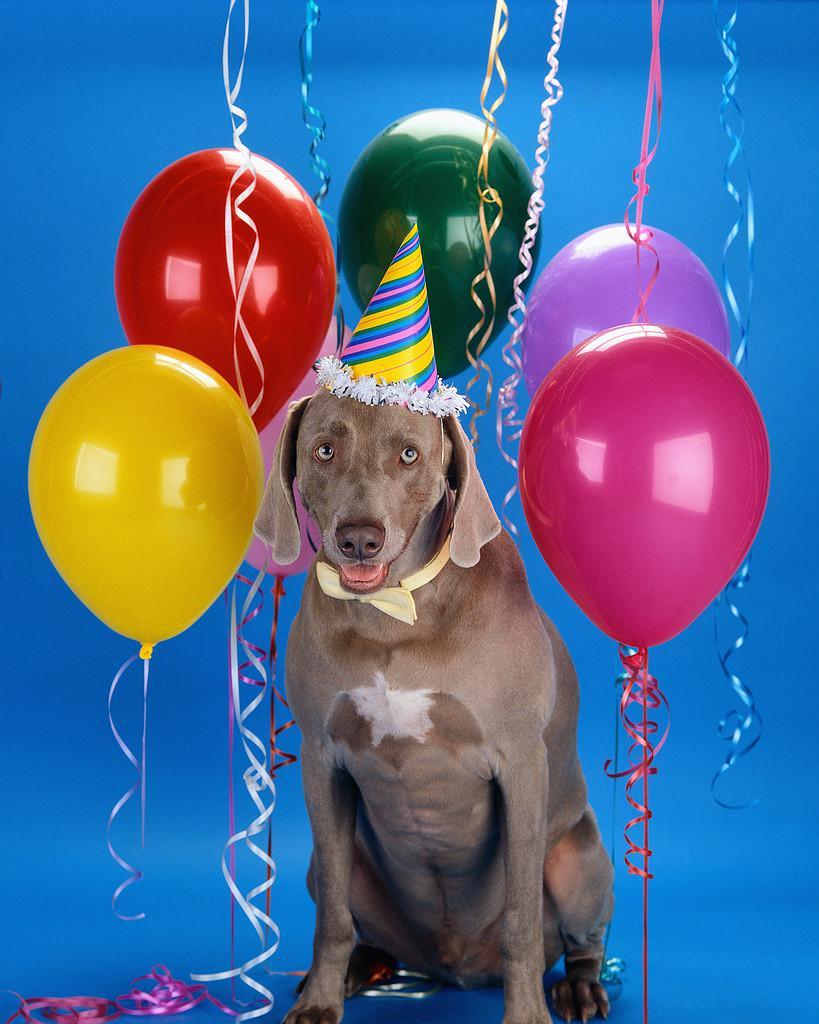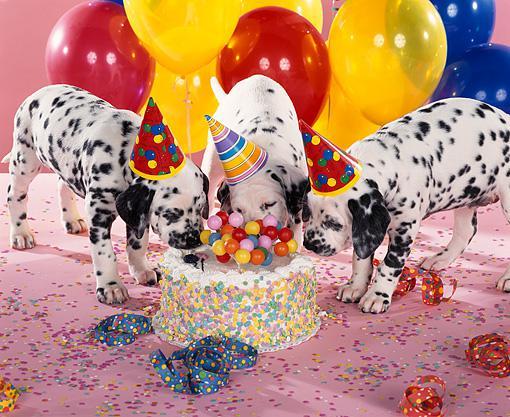The first image is the image on the left, the second image is the image on the right. Examine the images to the left and right. Is the description "There is exactly one dog in the right image." accurate? Answer yes or no. No. The first image is the image on the left, the second image is the image on the right. For the images shown, is this caption "Each image includes at least one dog wearing a cone-shaped party hat with balloons floating behind it." true? Answer yes or no. Yes. 